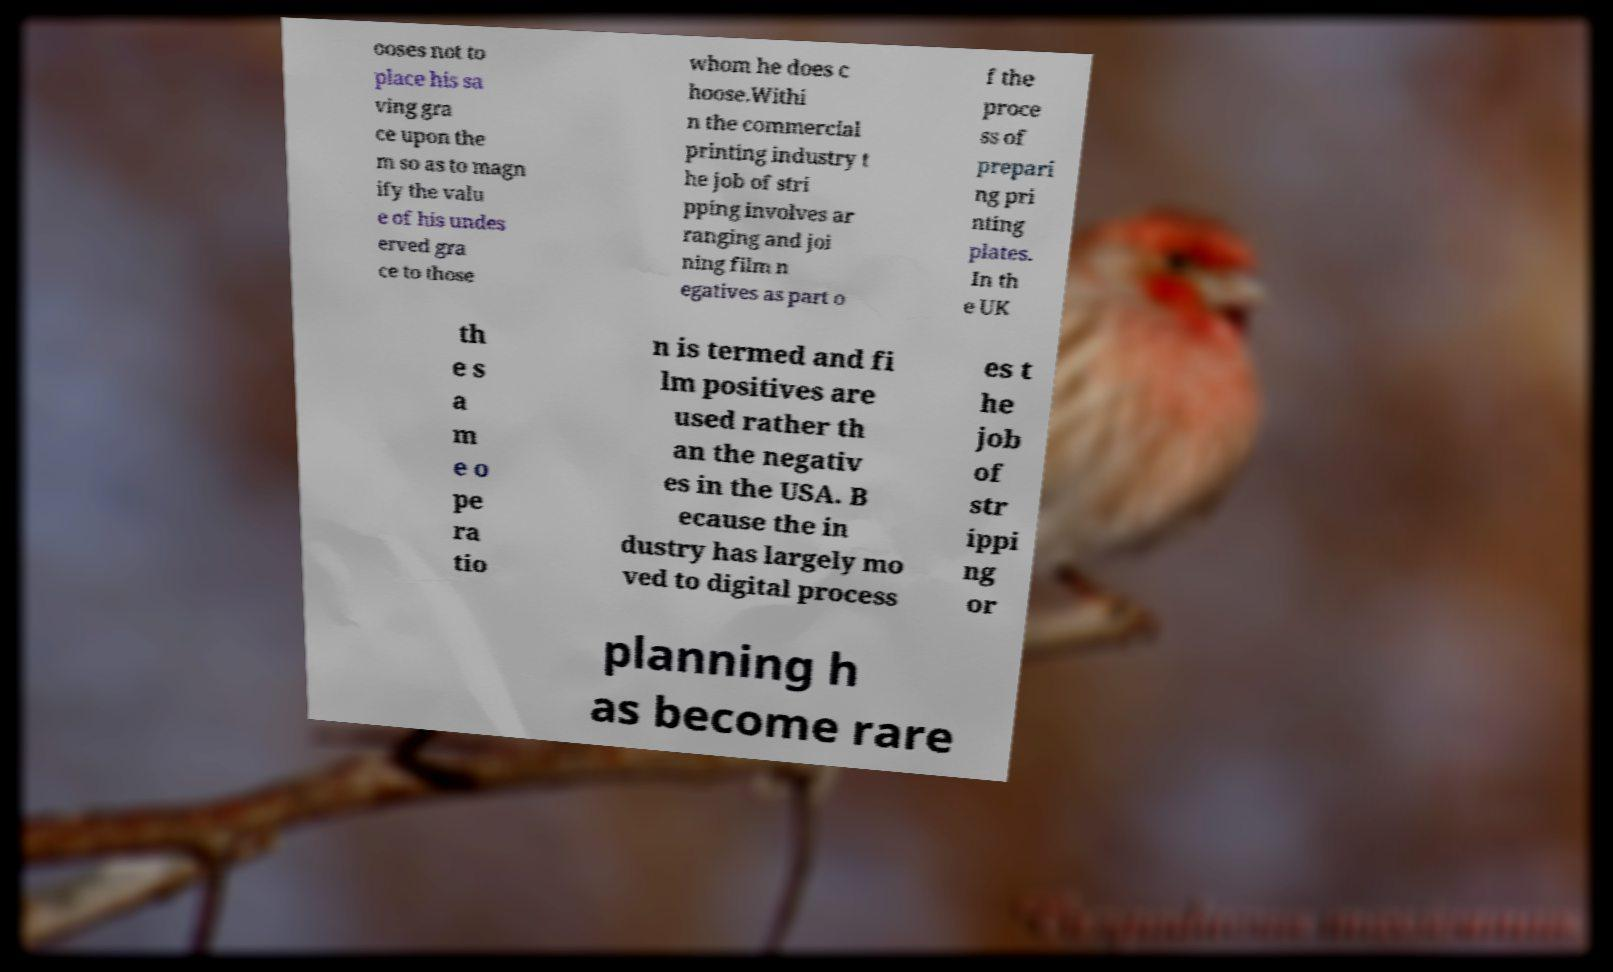Please read and relay the text visible in this image. What does it say? ooses not to place his sa ving gra ce upon the m so as to magn ify the valu e of his undes erved gra ce to those whom he does c hoose.Withi n the commercial printing industry t he job of stri pping involves ar ranging and joi ning film n egatives as part o f the proce ss of prepari ng pri nting plates. In th e UK th e s a m e o pe ra tio n is termed and fi lm positives are used rather th an the negativ es in the USA. B ecause the in dustry has largely mo ved to digital process es t he job of str ippi ng or planning h as become rare 